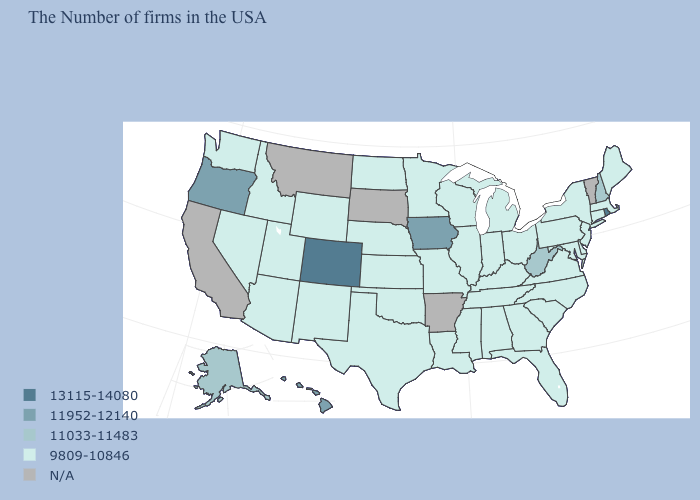Name the states that have a value in the range 9809-10846?
Keep it brief. Maine, Massachusetts, Connecticut, New York, New Jersey, Delaware, Maryland, Pennsylvania, Virginia, North Carolina, South Carolina, Ohio, Florida, Georgia, Michigan, Kentucky, Indiana, Alabama, Tennessee, Wisconsin, Illinois, Mississippi, Louisiana, Missouri, Minnesota, Kansas, Nebraska, Oklahoma, Texas, North Dakota, Wyoming, New Mexico, Utah, Arizona, Idaho, Nevada, Washington. What is the value of West Virginia?
Quick response, please. 11033-11483. Name the states that have a value in the range 9809-10846?
Keep it brief. Maine, Massachusetts, Connecticut, New York, New Jersey, Delaware, Maryland, Pennsylvania, Virginia, North Carolina, South Carolina, Ohio, Florida, Georgia, Michigan, Kentucky, Indiana, Alabama, Tennessee, Wisconsin, Illinois, Mississippi, Louisiana, Missouri, Minnesota, Kansas, Nebraska, Oklahoma, Texas, North Dakota, Wyoming, New Mexico, Utah, Arizona, Idaho, Nevada, Washington. What is the value of Indiana?
Write a very short answer. 9809-10846. Does Maine have the highest value in the Northeast?
Write a very short answer. No. Which states have the lowest value in the South?
Concise answer only. Delaware, Maryland, Virginia, North Carolina, South Carolina, Florida, Georgia, Kentucky, Alabama, Tennessee, Mississippi, Louisiana, Oklahoma, Texas. Name the states that have a value in the range 11952-12140?
Concise answer only. Iowa, Oregon, Hawaii. Among the states that border Nevada , which have the lowest value?
Answer briefly. Utah, Arizona, Idaho. What is the highest value in the Northeast ?
Write a very short answer. 13115-14080. Which states hav the highest value in the Northeast?
Concise answer only. Rhode Island. Which states hav the highest value in the West?
Give a very brief answer. Colorado. What is the value of Minnesota?
Short answer required. 9809-10846. What is the lowest value in the South?
Write a very short answer. 9809-10846. 